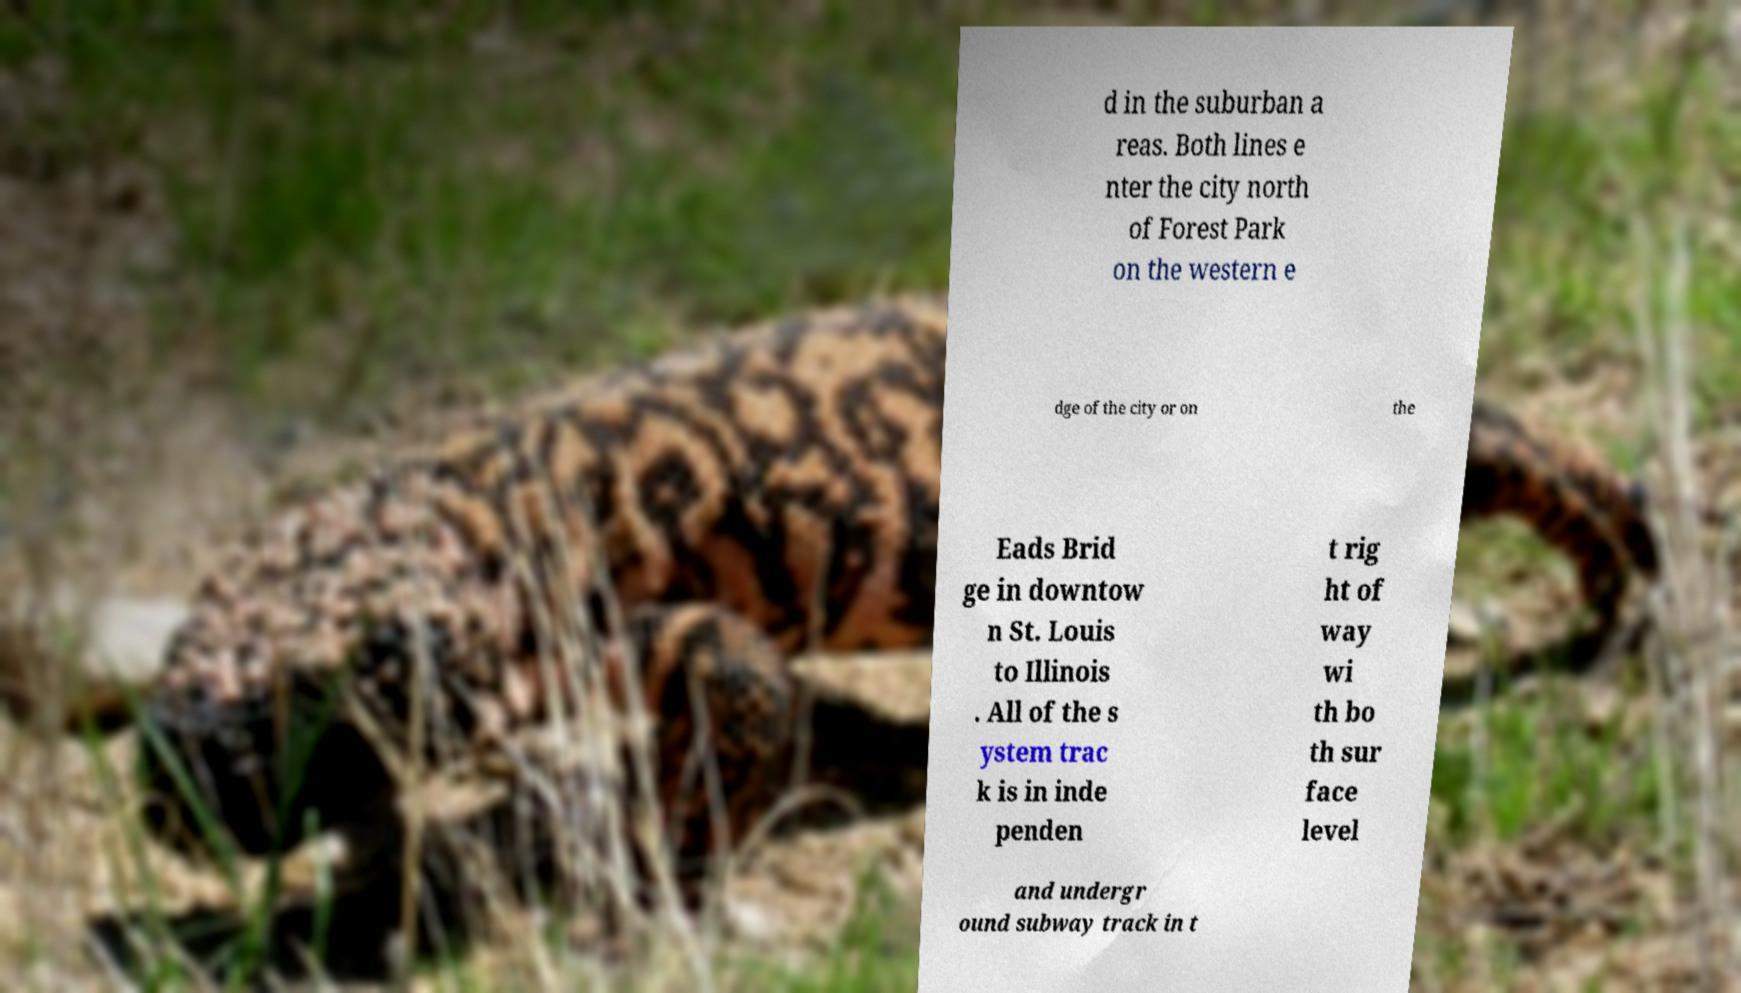Can you read and provide the text displayed in the image?This photo seems to have some interesting text. Can you extract and type it out for me? d in the suburban a reas. Both lines e nter the city north of Forest Park on the western e dge of the city or on the Eads Brid ge in downtow n St. Louis to Illinois . All of the s ystem trac k is in inde penden t rig ht of way wi th bo th sur face level and undergr ound subway track in t 